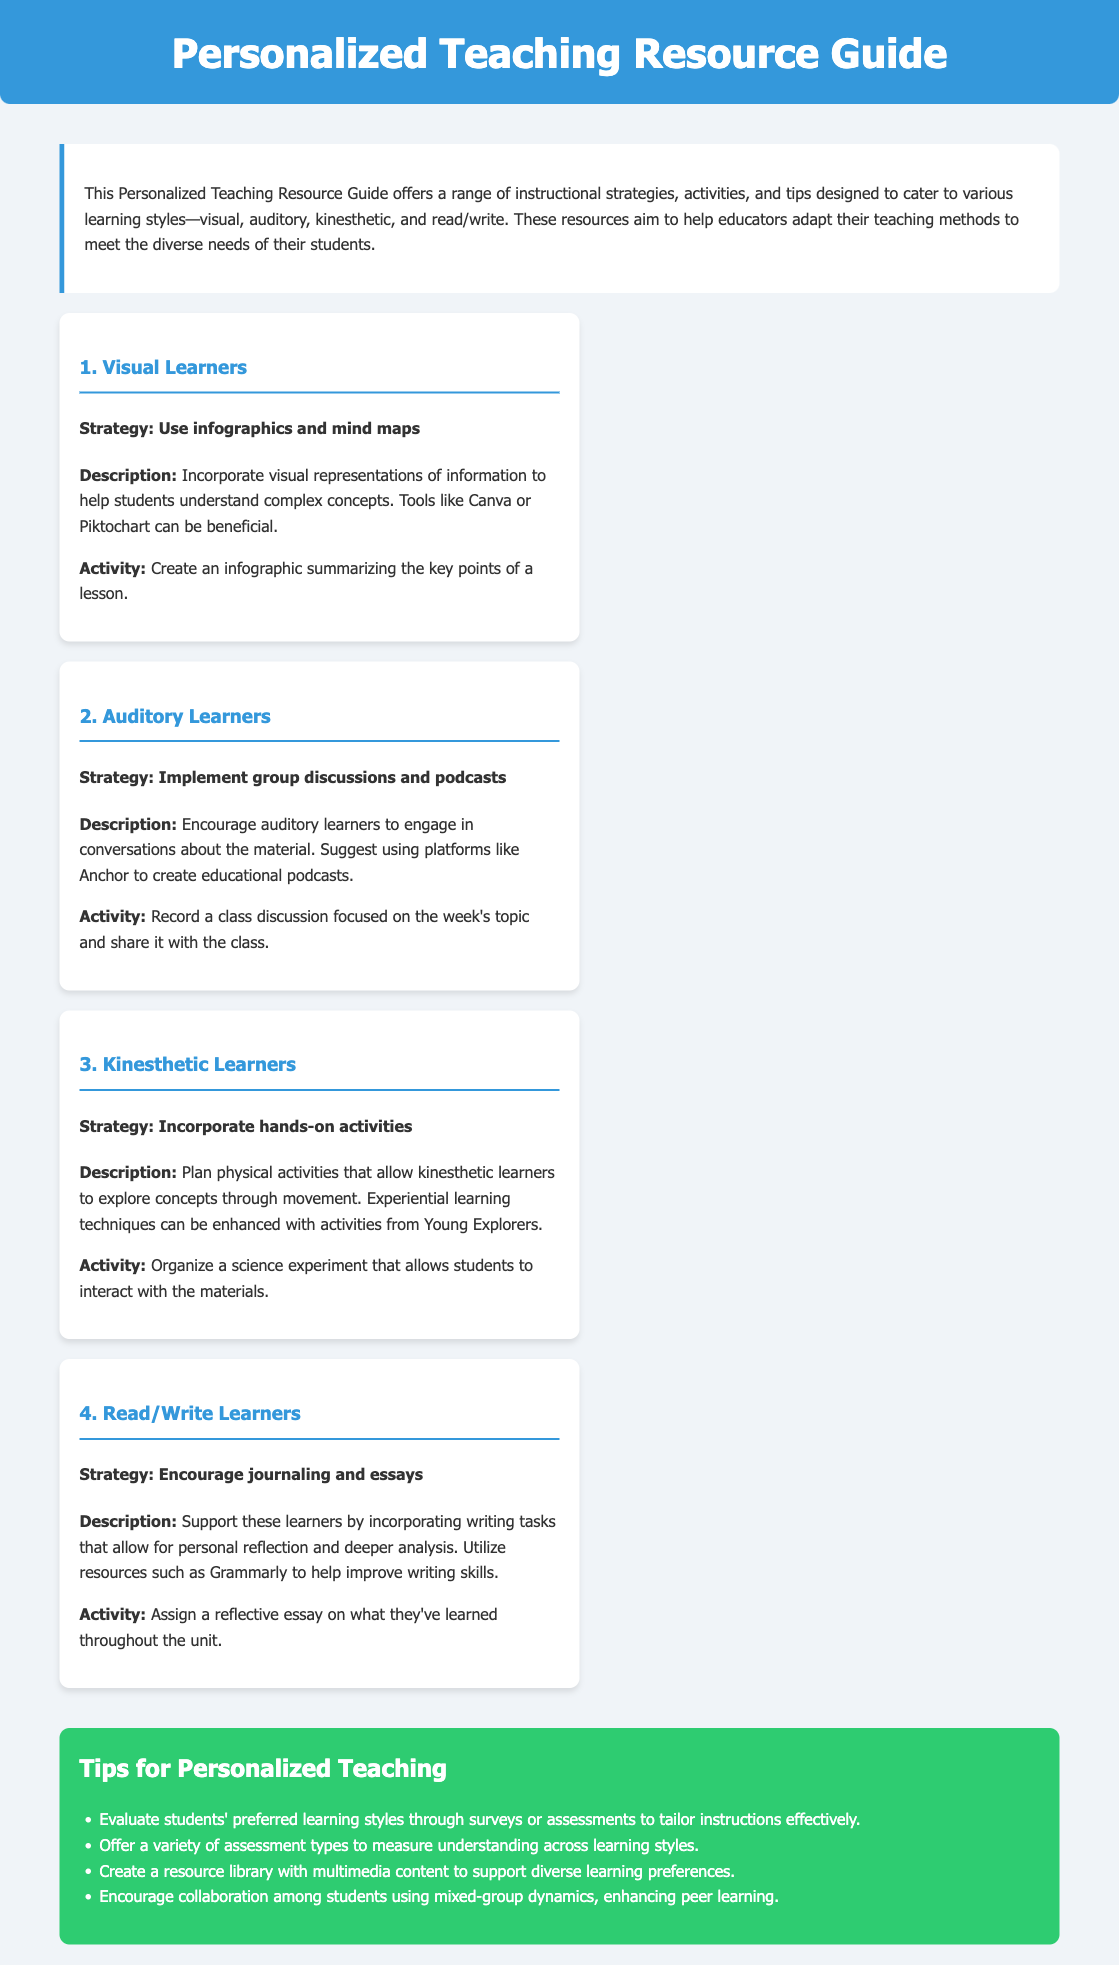What is the title of the document? The title of the document is presented in the header section of the HTML, which states the primary subject of the content.
Answer: Personalized Teaching Resource Guide How many learning styles are addressed in the guide? The guide mentions four distinct learning styles that are catered to with specific strategies and activities.
Answer: Four What strategy is suggested for visual learners? The document outlines a specific instructional strategy for visual learners, which is prominently noted within that section.
Answer: Use infographics and mind maps Which tool is recommended for creating educational podcasts? The guide specifies a platform that auditory learners can use for creating podcasts in the relevant section.
Answer: Anchor What type of activity is suggested for kinesthetic learners? The document describes a hands-on activity tailored for kinesthetic learners, clearly identified under their respective section.
Answer: Organize a science experiment What is one tip provided for personalized teaching? The tips section lists several strategies, and one of them can be extracted based on what is written in the bullets.
Answer: Evaluate students' preferred learning styles What type of writing task is encouraged for read/write learners? The document specifies the kind of writing task that supports read/write learners in their learning process.
Answer: Reflective essay What color is used for the tips section? The document describes the background color associated with the tips section, contributing to its visual identity.
Answer: Green 